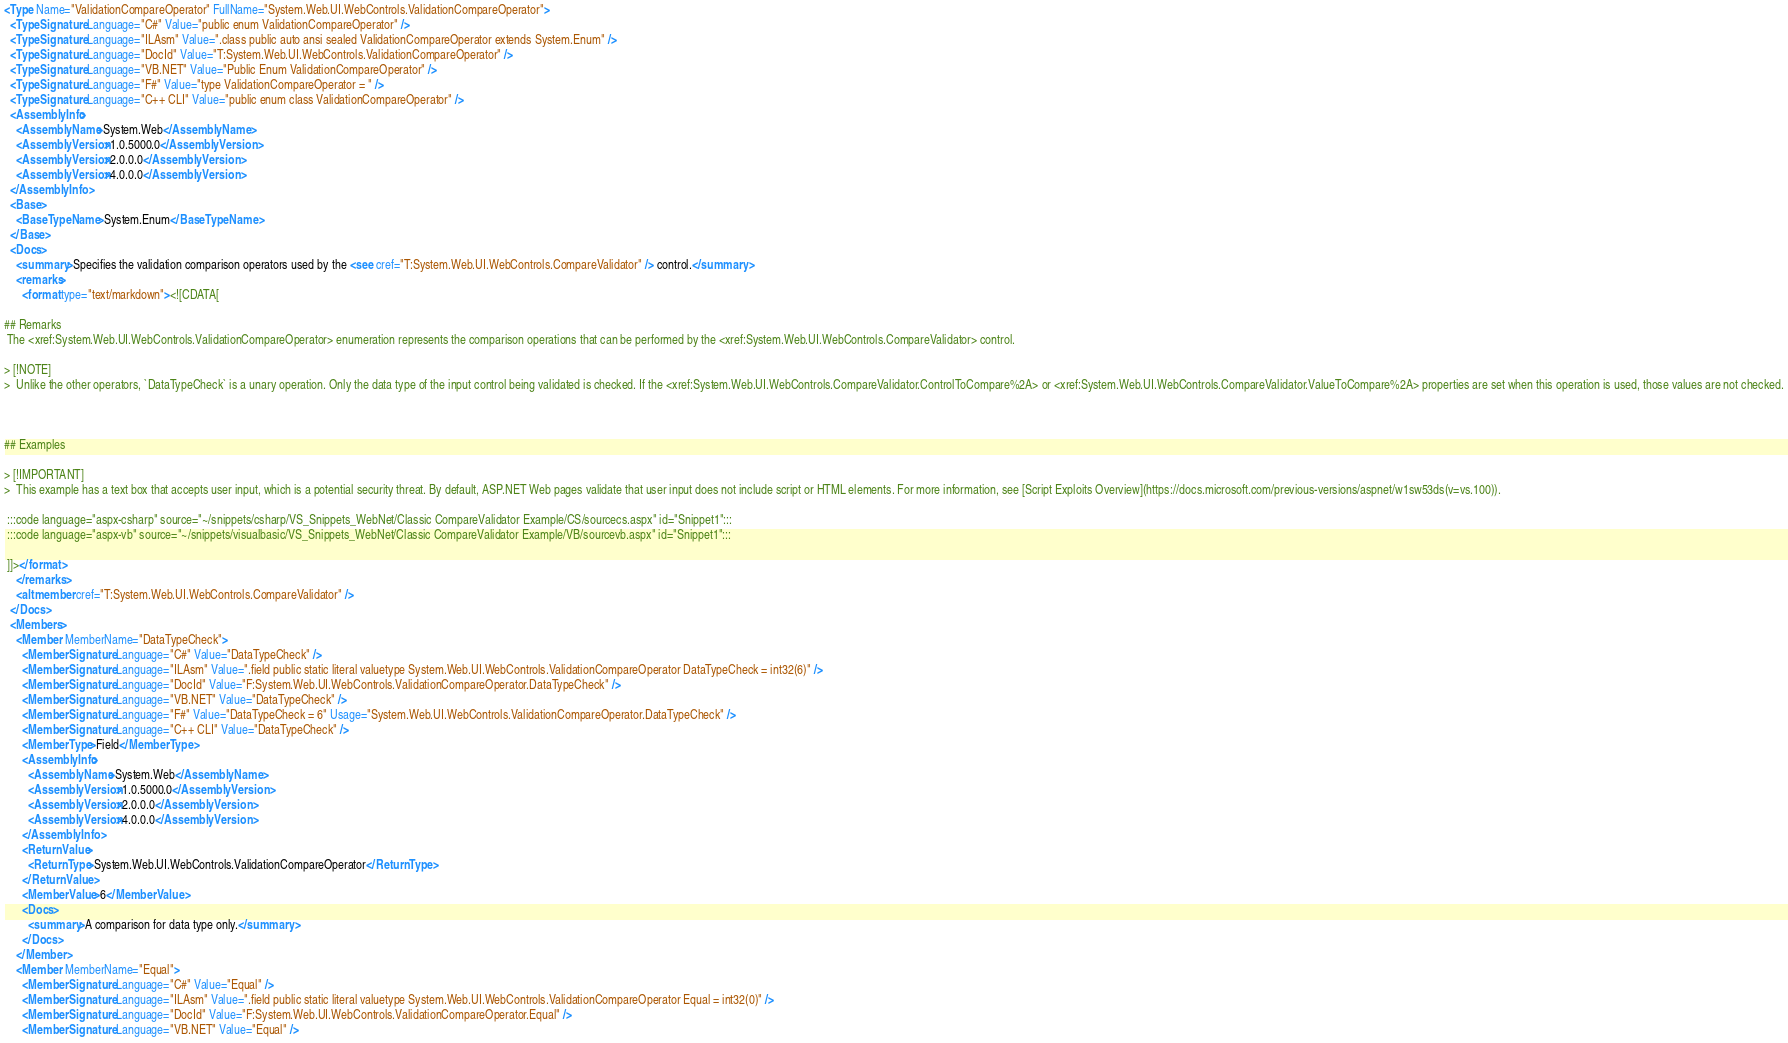<code> <loc_0><loc_0><loc_500><loc_500><_XML_><Type Name="ValidationCompareOperator" FullName="System.Web.UI.WebControls.ValidationCompareOperator">
  <TypeSignature Language="C#" Value="public enum ValidationCompareOperator" />
  <TypeSignature Language="ILAsm" Value=".class public auto ansi sealed ValidationCompareOperator extends System.Enum" />
  <TypeSignature Language="DocId" Value="T:System.Web.UI.WebControls.ValidationCompareOperator" />
  <TypeSignature Language="VB.NET" Value="Public Enum ValidationCompareOperator" />
  <TypeSignature Language="F#" Value="type ValidationCompareOperator = " />
  <TypeSignature Language="C++ CLI" Value="public enum class ValidationCompareOperator" />
  <AssemblyInfo>
    <AssemblyName>System.Web</AssemblyName>
    <AssemblyVersion>1.0.5000.0</AssemblyVersion>
    <AssemblyVersion>2.0.0.0</AssemblyVersion>
    <AssemblyVersion>4.0.0.0</AssemblyVersion>
  </AssemblyInfo>
  <Base>
    <BaseTypeName>System.Enum</BaseTypeName>
  </Base>
  <Docs>
    <summary>Specifies the validation comparison operators used by the <see cref="T:System.Web.UI.WebControls.CompareValidator" /> control.</summary>
    <remarks>
      <format type="text/markdown"><![CDATA[

## Remarks
 The <xref:System.Web.UI.WebControls.ValidationCompareOperator> enumeration represents the comparison operations that can be performed by the <xref:System.Web.UI.WebControls.CompareValidator> control.

> [!NOTE]
>  Unlike the other operators, `DataTypeCheck` is a unary operation. Only the data type of the input control being validated is checked. If the <xref:System.Web.UI.WebControls.CompareValidator.ControlToCompare%2A> or <xref:System.Web.UI.WebControls.CompareValidator.ValueToCompare%2A> properties are set when this operation is used, those values are not checked.



## Examples

> [!IMPORTANT]
>  This example has a text box that accepts user input, which is a potential security threat. By default, ASP.NET Web pages validate that user input does not include script or HTML elements. For more information, see [Script Exploits Overview](https://docs.microsoft.com/previous-versions/aspnet/w1sw53ds(v=vs.100)).

 :::code language="aspx-csharp" source="~/snippets/csharp/VS_Snippets_WebNet/Classic CompareValidator Example/CS/sourcecs.aspx" id="Snippet1":::
 :::code language="aspx-vb" source="~/snippets/visualbasic/VS_Snippets_WebNet/Classic CompareValidator Example/VB/sourcevb.aspx" id="Snippet1":::

 ]]></format>
    </remarks>
    <altmember cref="T:System.Web.UI.WebControls.CompareValidator" />
  </Docs>
  <Members>
    <Member MemberName="DataTypeCheck">
      <MemberSignature Language="C#" Value="DataTypeCheck" />
      <MemberSignature Language="ILAsm" Value=".field public static literal valuetype System.Web.UI.WebControls.ValidationCompareOperator DataTypeCheck = int32(6)" />
      <MemberSignature Language="DocId" Value="F:System.Web.UI.WebControls.ValidationCompareOperator.DataTypeCheck" />
      <MemberSignature Language="VB.NET" Value="DataTypeCheck" />
      <MemberSignature Language="F#" Value="DataTypeCheck = 6" Usage="System.Web.UI.WebControls.ValidationCompareOperator.DataTypeCheck" />
      <MemberSignature Language="C++ CLI" Value="DataTypeCheck" />
      <MemberType>Field</MemberType>
      <AssemblyInfo>
        <AssemblyName>System.Web</AssemblyName>
        <AssemblyVersion>1.0.5000.0</AssemblyVersion>
        <AssemblyVersion>2.0.0.0</AssemblyVersion>
        <AssemblyVersion>4.0.0.0</AssemblyVersion>
      </AssemblyInfo>
      <ReturnValue>
        <ReturnType>System.Web.UI.WebControls.ValidationCompareOperator</ReturnType>
      </ReturnValue>
      <MemberValue>6</MemberValue>
      <Docs>
        <summary>A comparison for data type only.</summary>
      </Docs>
    </Member>
    <Member MemberName="Equal">
      <MemberSignature Language="C#" Value="Equal" />
      <MemberSignature Language="ILAsm" Value=".field public static literal valuetype System.Web.UI.WebControls.ValidationCompareOperator Equal = int32(0)" />
      <MemberSignature Language="DocId" Value="F:System.Web.UI.WebControls.ValidationCompareOperator.Equal" />
      <MemberSignature Language="VB.NET" Value="Equal" /></code> 